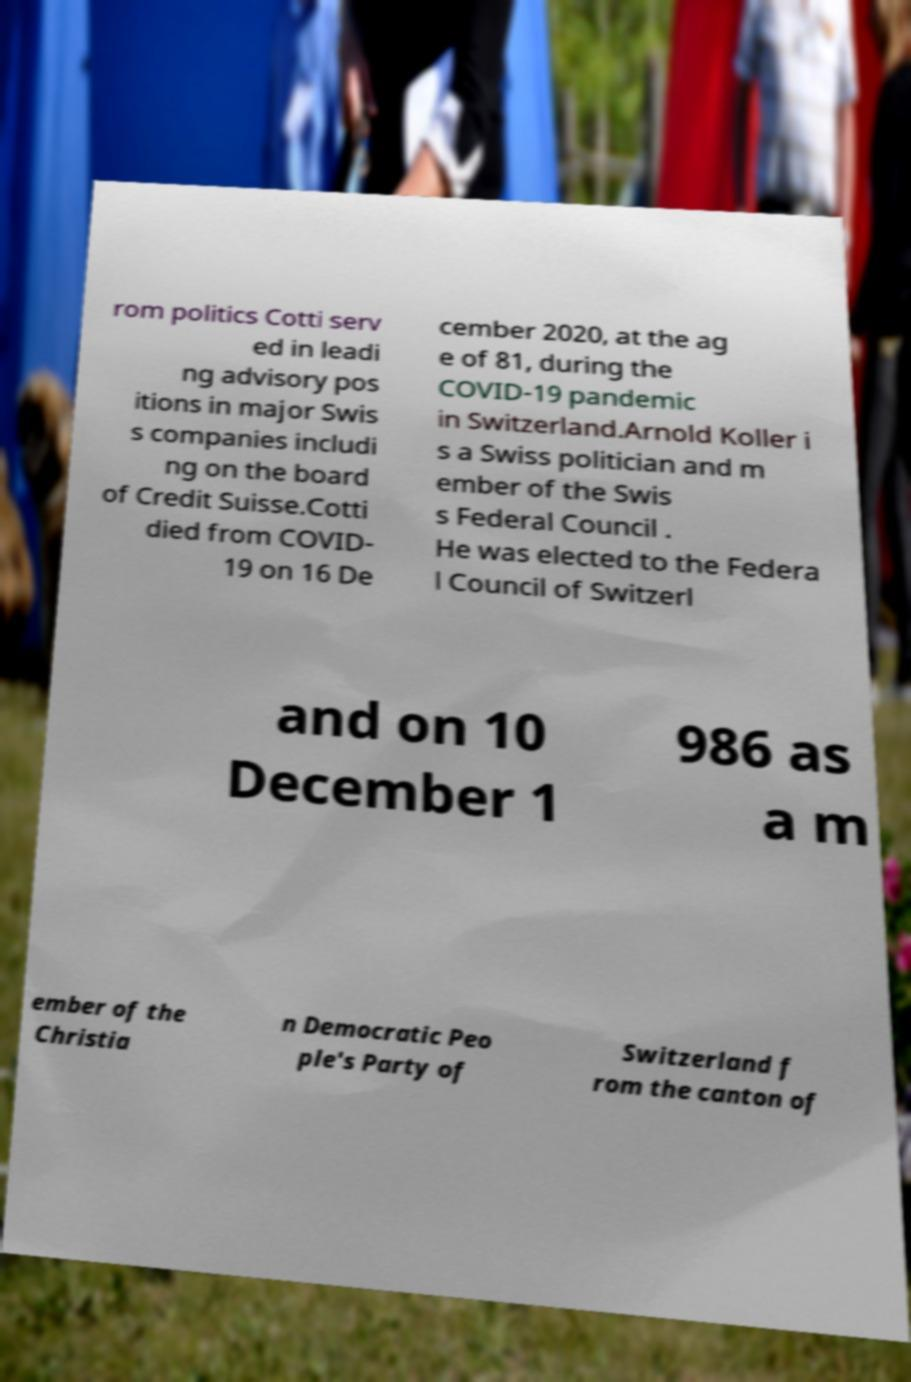Can you read and provide the text displayed in the image?This photo seems to have some interesting text. Can you extract and type it out for me? rom politics Cotti serv ed in leadi ng advisory pos itions in major Swis s companies includi ng on the board of Credit Suisse.Cotti died from COVID- 19 on 16 De cember 2020, at the ag e of 81, during the COVID-19 pandemic in Switzerland.Arnold Koller i s a Swiss politician and m ember of the Swis s Federal Council . He was elected to the Federa l Council of Switzerl and on 10 December 1 986 as a m ember of the Christia n Democratic Peo ple's Party of Switzerland f rom the canton of 